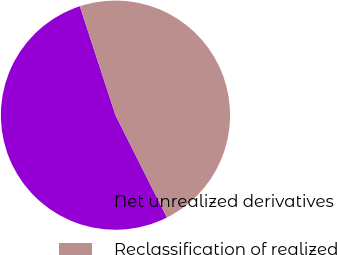Convert chart. <chart><loc_0><loc_0><loc_500><loc_500><pie_chart><fcel>Net unrealized derivatives<fcel>Reclassification of realized<nl><fcel>52.38%<fcel>47.62%<nl></chart> 